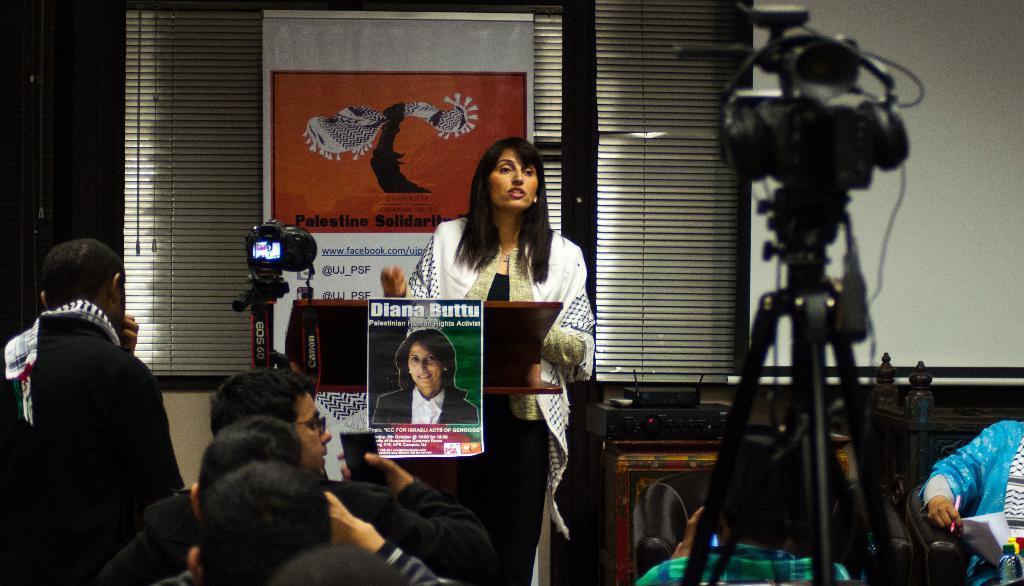Could you give a brief overview of what you see in this image? In the picture I can see there is a woman standing here behind the wooden table and there is a screen and a banner. There are few people in front of her and they are holding cameras. 